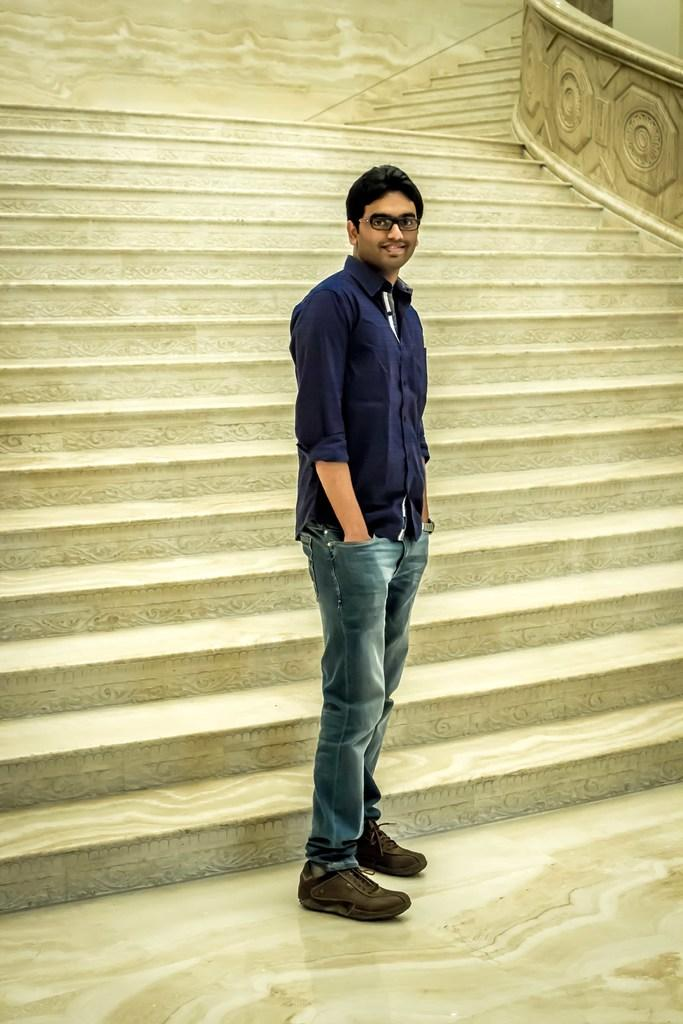Who is the main subject in the image? There is a man in the middle of the image. What is the man doing in the image? The man is smiling. What architectural feature can be seen behind the man? There are steps visible behind the man. What type of cherry is the man holding in the image? There is no cherry present in the image; the man is simply smiling. 